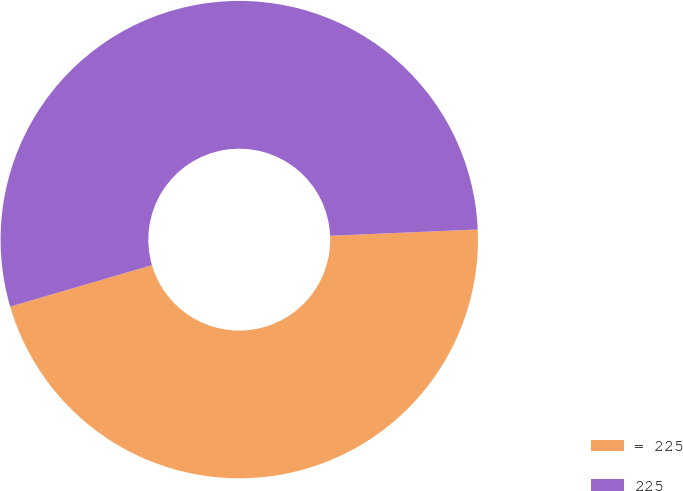Convert chart. <chart><loc_0><loc_0><loc_500><loc_500><pie_chart><fcel>= 225<fcel>225<nl><fcel>46.15%<fcel>53.85%<nl></chart> 